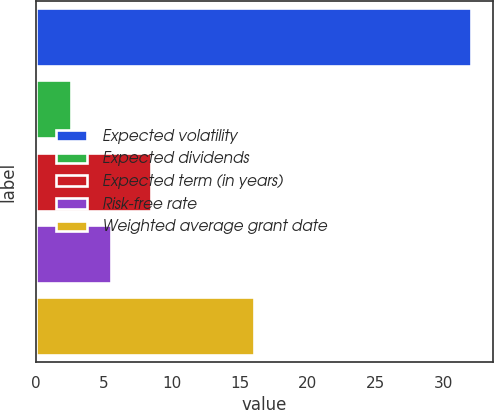<chart> <loc_0><loc_0><loc_500><loc_500><bar_chart><fcel>Expected volatility<fcel>Expected dividends<fcel>Expected term (in years)<fcel>Risk-free rate<fcel>Weighted average grant date<nl><fcel>32.02<fcel>2.55<fcel>8.45<fcel>5.5<fcel>16.03<nl></chart> 